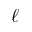<formula> <loc_0><loc_0><loc_500><loc_500>\ell</formula> 